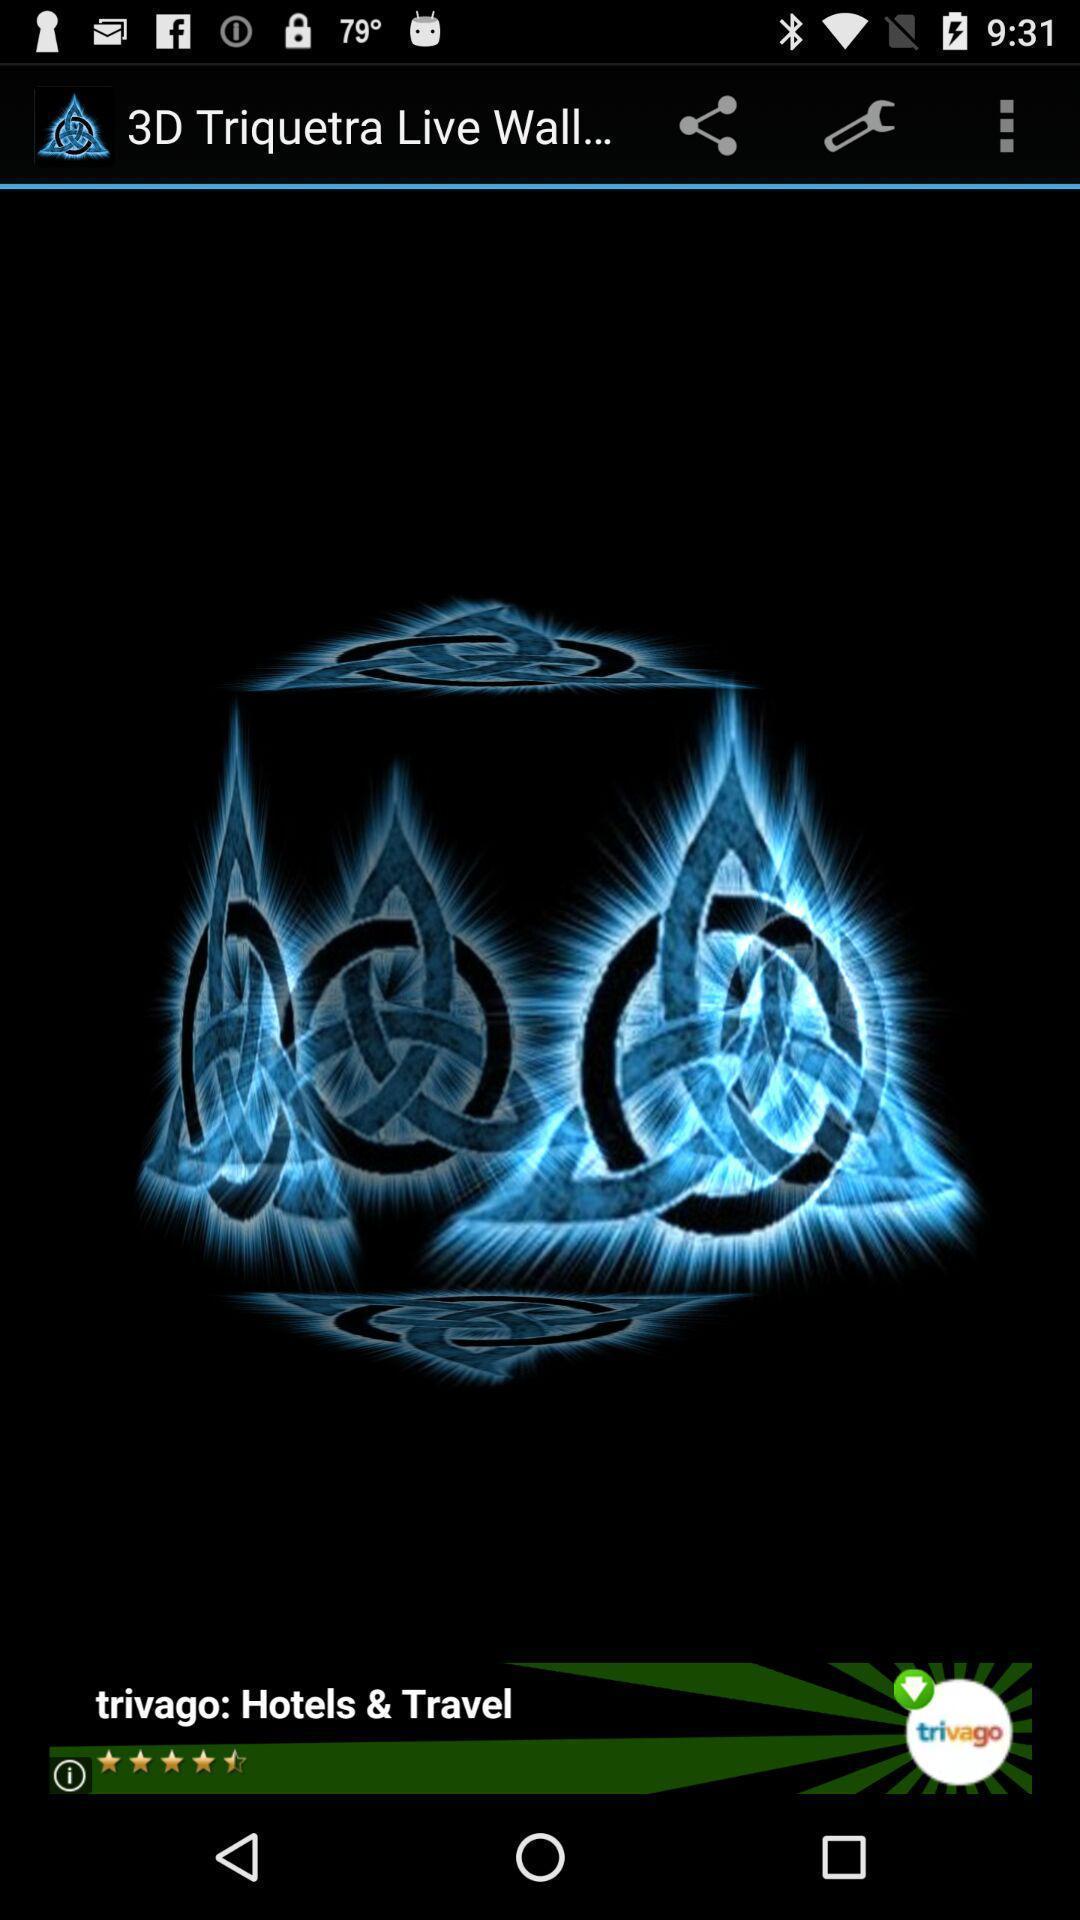Provide a textual representation of this image. Page showing the image of 3d live wallpaper. 